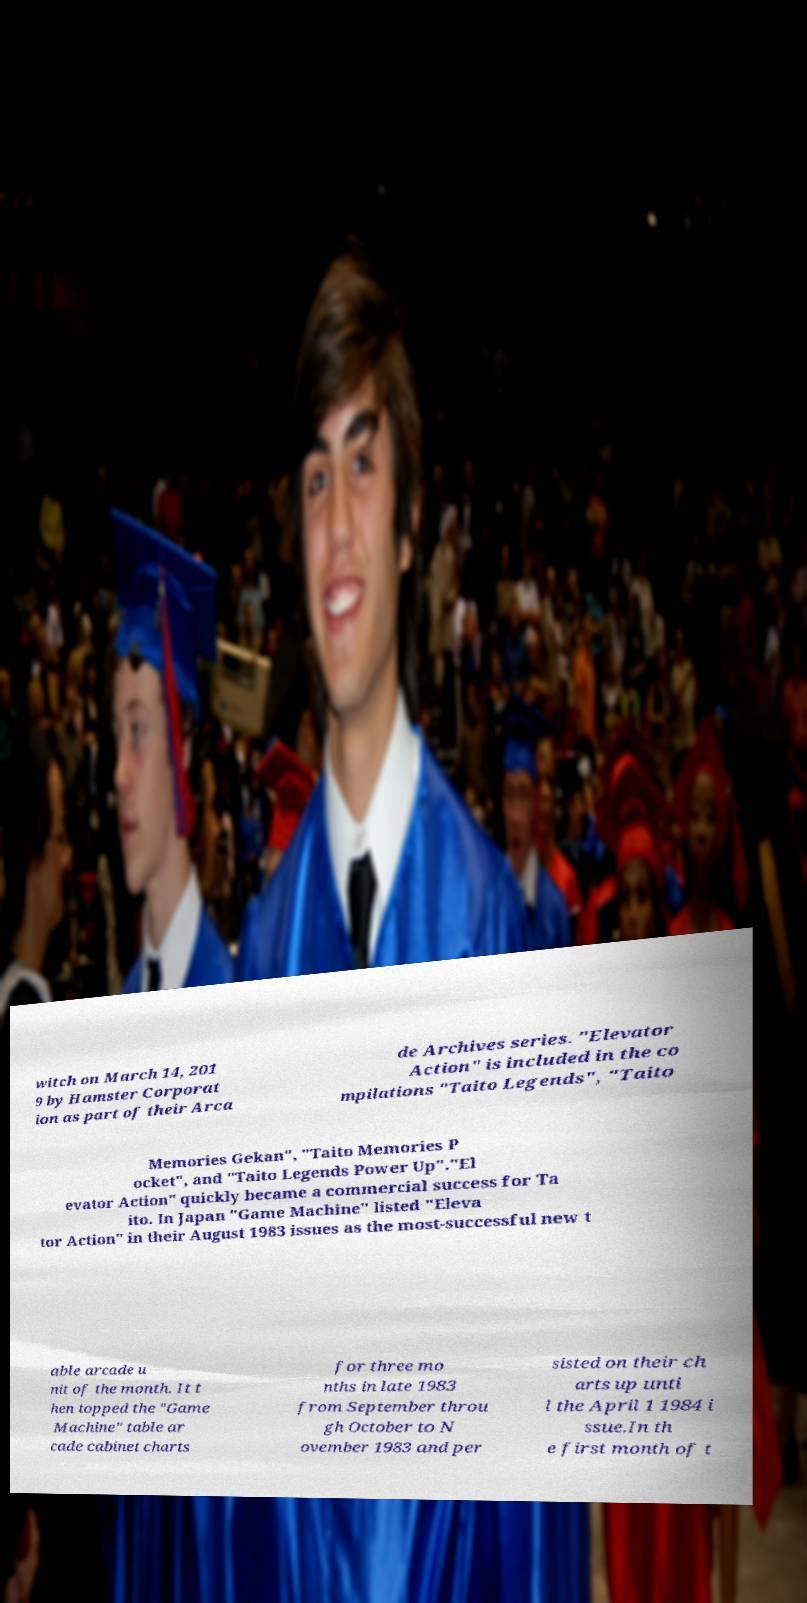Can you accurately transcribe the text from the provided image for me? witch on March 14, 201 9 by Hamster Corporat ion as part of their Arca de Archives series. "Elevator Action" is included in the co mpilations "Taito Legends", "Taito Memories Gekan", "Taito Memories P ocket", and "Taito Legends Power Up"."El evator Action" quickly became a commercial success for Ta ito. In Japan "Game Machine" listed "Eleva tor Action" in their August 1983 issues as the most-successful new t able arcade u nit of the month. It t hen topped the "Game Machine" table ar cade cabinet charts for three mo nths in late 1983 from September throu gh October to N ovember 1983 and per sisted on their ch arts up unti l the April 1 1984 i ssue.In th e first month of t 